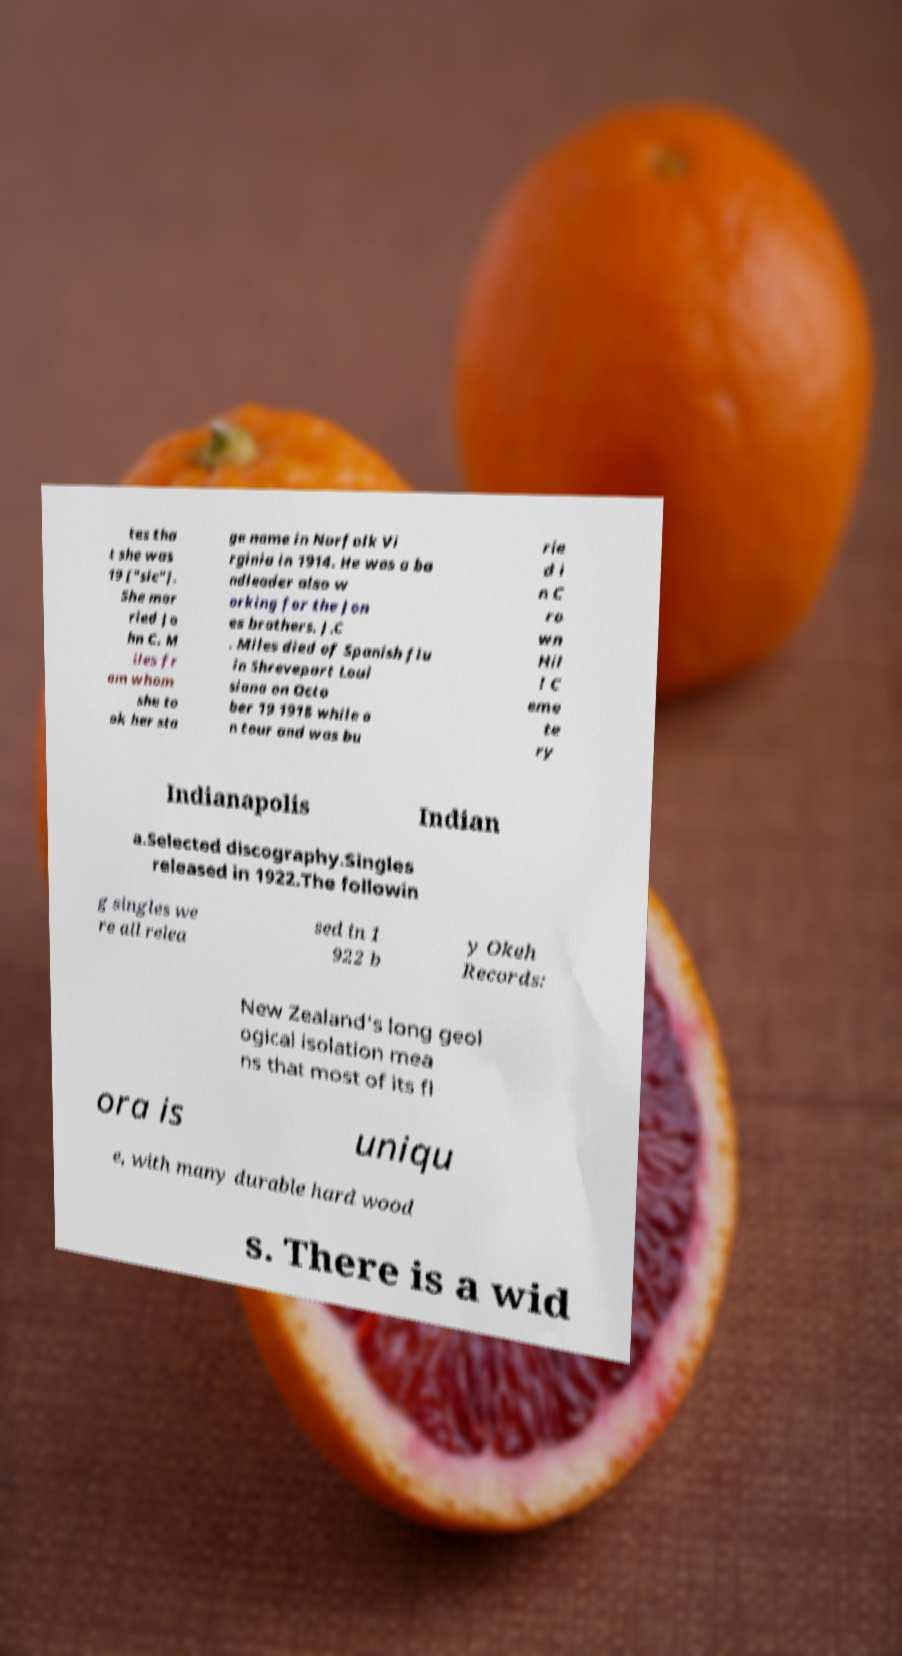For documentation purposes, I need the text within this image transcribed. Could you provide that? tes tha t she was 19 ["sic"]. She mar ried Jo hn C. M iles fr om whom she to ok her sta ge name in Norfolk Vi rginia in 1914. He was a ba ndleader also w orking for the Jon es brothers. J.C . Miles died of Spanish flu in Shreveport Loui siana on Octo ber 19 1918 while o n tour and was bu rie d i n C ro wn Hil l C eme te ry Indianapolis Indian a.Selected discography.Singles released in 1922.The followin g singles we re all relea sed in 1 922 b y Okeh Records: New Zealand's long geol ogical isolation mea ns that most of its fl ora is uniqu e, with many durable hard wood s. There is a wid 